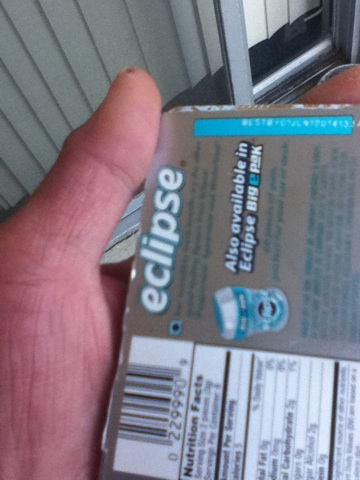What brand is this gum and what flavor is it? The brand of the gum is Eclipse, but unfortunately, due to the blur in the image, the flavor cannot be determined from the visible information. 